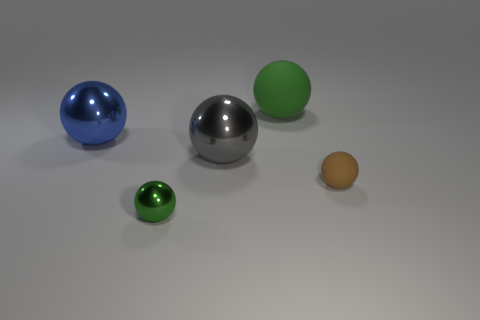What number of balls have the same material as the tiny green thing?
Offer a terse response. 2. Does the big rubber ball have the same color as the large metallic object in front of the large blue object?
Give a very brief answer. No. The large shiny sphere that is left of the large metal ball to the right of the blue sphere is what color?
Keep it short and to the point. Blue. There is a matte ball that is the same size as the blue thing; what is its color?
Provide a short and direct response. Green. Are there any tiny yellow things that have the same shape as the large green object?
Make the answer very short. No. Is the number of green metal balls that are in front of the green matte sphere greater than the number of small green things that are behind the gray metallic ball?
Provide a succinct answer. Yes. What number of other objects are the same size as the blue shiny thing?
Ensure brevity in your answer.  2. There is a ball that is both right of the big gray object and behind the brown object; what material is it?
Keep it short and to the point. Rubber. There is a small brown object that is the same shape as the large blue metal thing; what is it made of?
Make the answer very short. Rubber. There is a thing behind the big object that is on the left side of the large gray shiny thing; how many green spheres are to the right of it?
Provide a succinct answer. 0. 